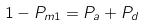<formula> <loc_0><loc_0><loc_500><loc_500>1 - P _ { m 1 } = P _ { a } + P _ { d }</formula> 